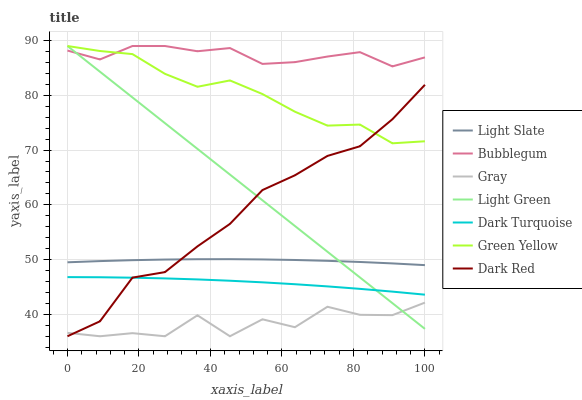Does Gray have the minimum area under the curve?
Answer yes or no. Yes. Does Bubblegum have the maximum area under the curve?
Answer yes or no. Yes. Does Light Slate have the minimum area under the curve?
Answer yes or no. No. Does Light Slate have the maximum area under the curve?
Answer yes or no. No. Is Light Green the smoothest?
Answer yes or no. Yes. Is Gray the roughest?
Answer yes or no. Yes. Is Light Slate the smoothest?
Answer yes or no. No. Is Light Slate the roughest?
Answer yes or no. No. Does Gray have the lowest value?
Answer yes or no. Yes. Does Light Slate have the lowest value?
Answer yes or no. No. Does Green Yellow have the highest value?
Answer yes or no. Yes. Does Light Slate have the highest value?
Answer yes or no. No. Is Dark Turquoise less than Light Slate?
Answer yes or no. Yes. Is Green Yellow greater than Light Slate?
Answer yes or no. Yes. Does Light Slate intersect Light Green?
Answer yes or no. Yes. Is Light Slate less than Light Green?
Answer yes or no. No. Is Light Slate greater than Light Green?
Answer yes or no. No. Does Dark Turquoise intersect Light Slate?
Answer yes or no. No. 